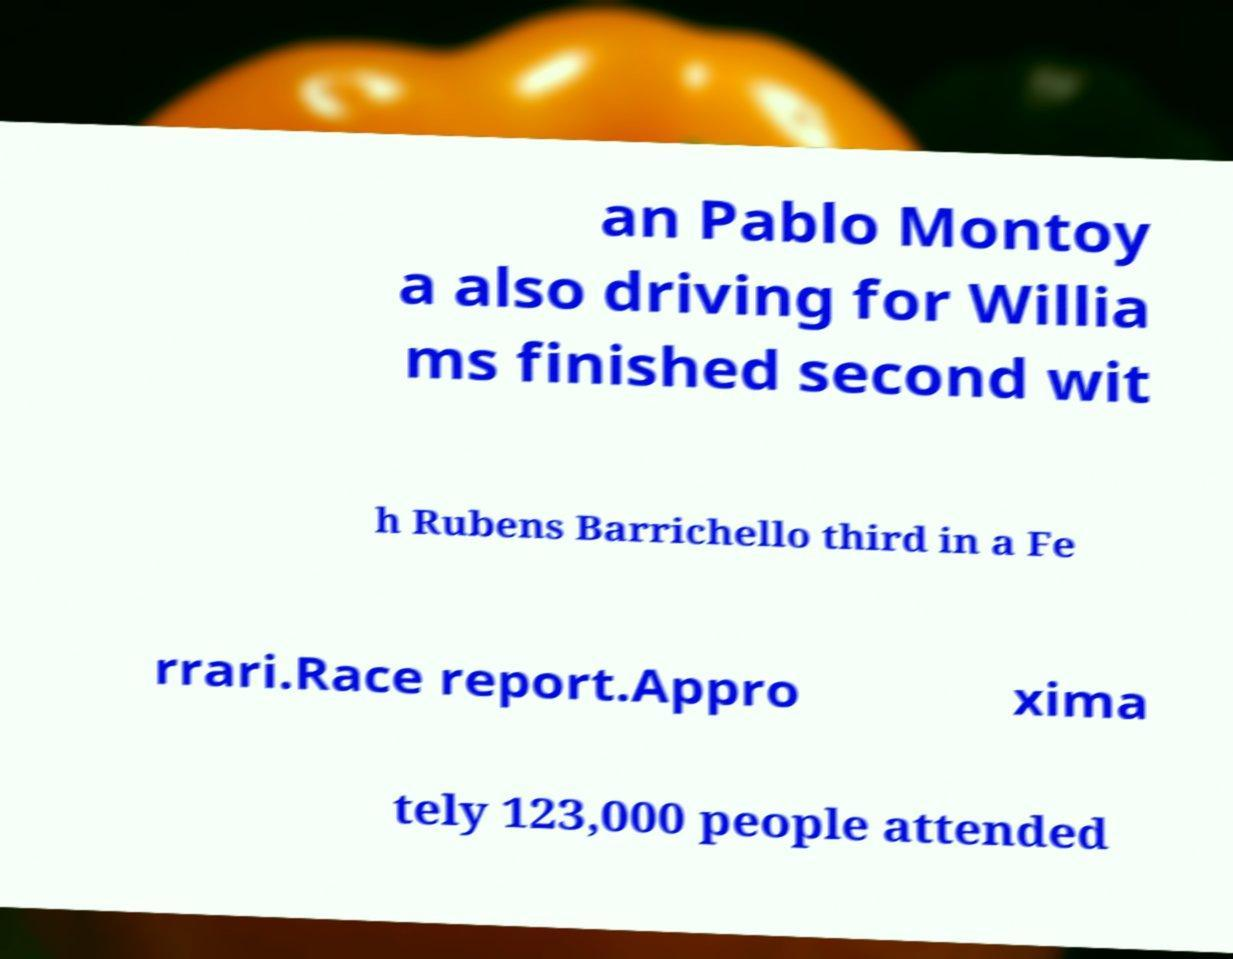Could you assist in decoding the text presented in this image and type it out clearly? an Pablo Montoy a also driving for Willia ms finished second wit h Rubens Barrichello third in a Fe rrari.Race report.Appro xima tely 123,000 people attended 